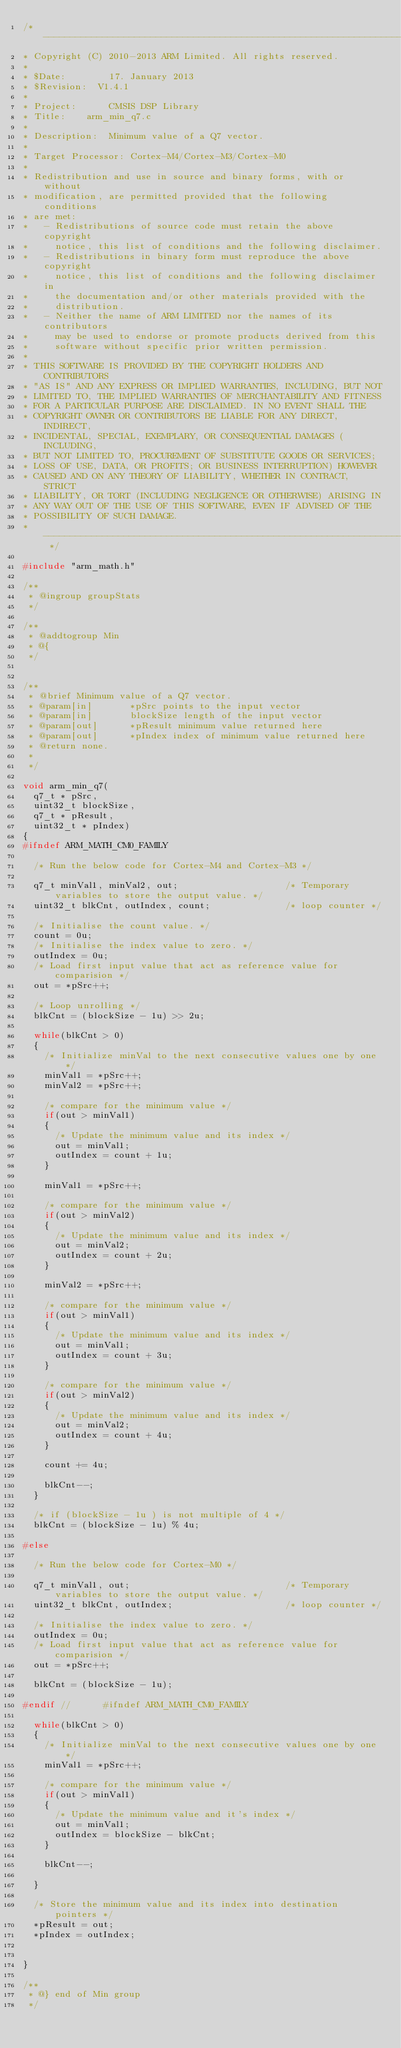<code> <loc_0><loc_0><loc_500><loc_500><_C_>/* ----------------------------------------------------------------------    
* Copyright (C) 2010-2013 ARM Limited. All rights reserved.    
*    
* $Date:        17. January 2013
* $Revision: 	V1.4.1  
*    
* Project: 	    CMSIS DSP Library    
* Title:		arm_min_q7.c    
*    
* Description:	Minimum value of a Q7 vector.    
*    
* Target Processor: Cortex-M4/Cortex-M3/Cortex-M0
*  
* Redistribution and use in source and binary forms, with or without 
* modification, are permitted provided that the following conditions
* are met:
*   - Redistributions of source code must retain the above copyright
*     notice, this list of conditions and the following disclaimer.
*   - Redistributions in binary form must reproduce the above copyright
*     notice, this list of conditions and the following disclaimer in
*     the documentation and/or other materials provided with the 
*     distribution.
*   - Neither the name of ARM LIMITED nor the names of its contributors
*     may be used to endorse or promote products derived from this
*     software without specific prior written permission.
*
* THIS SOFTWARE IS PROVIDED BY THE COPYRIGHT HOLDERS AND CONTRIBUTORS
* "AS IS" AND ANY EXPRESS OR IMPLIED WARRANTIES, INCLUDING, BUT NOT
* LIMITED TO, THE IMPLIED WARRANTIES OF MERCHANTABILITY AND FITNESS
* FOR A PARTICULAR PURPOSE ARE DISCLAIMED. IN NO EVENT SHALL THE 
* COPYRIGHT OWNER OR CONTRIBUTORS BE LIABLE FOR ANY DIRECT, INDIRECT,
* INCIDENTAL, SPECIAL, EXEMPLARY, OR CONSEQUENTIAL DAMAGES (INCLUDING,
* BUT NOT LIMITED TO, PROCUREMENT OF SUBSTITUTE GOODS OR SERVICES;
* LOSS OF USE, DATA, OR PROFITS; OR BUSINESS INTERRUPTION) HOWEVER
* CAUSED AND ON ANY THEORY OF LIABILITY, WHETHER IN CONTRACT, STRICT
* LIABILITY, OR TORT (INCLUDING NEGLIGENCE OR OTHERWISE) ARISING IN
* ANY WAY OUT OF THE USE OF THIS SOFTWARE, EVEN IF ADVISED OF THE
* POSSIBILITY OF SUCH DAMAGE.     
* ---------------------------------------------------------------------------- */

#include "arm_math.h"

/**    
 * @ingroup groupStats    
 */

/**    
 * @addtogroup Min    
 * @{    
 */


/**    
 * @brief Minimum value of a Q7 vector.    
 * @param[in]       *pSrc points to the input vector    
 * @param[in]       blockSize length of the input vector    
 * @param[out]      *pResult minimum value returned here    
 * @param[out]      *pIndex index of minimum value returned here    
 * @return none.    
 *    
 */

void arm_min_q7(
  q7_t * pSrc,
  uint32_t blockSize,
  q7_t * pResult,
  uint32_t * pIndex)
{
#ifndef ARM_MATH_CM0_FAMILY

  /* Run the below code for Cortex-M4 and Cortex-M3 */

  q7_t minVal1, minVal2, out;                    /* Temporary variables to store the output value. */
  uint32_t blkCnt, outIndex, count;              /* loop counter */

  /* Initialise the count value. */
  count = 0u;
  /* Initialise the index value to zero. */
  outIndex = 0u;
  /* Load first input value that act as reference value for comparision */
  out = *pSrc++;

  /* Loop unrolling */
  blkCnt = (blockSize - 1u) >> 2u;

  while(blkCnt > 0)
  {
    /* Initialize minVal to the next consecutive values one by one */
    minVal1 = *pSrc++;
    minVal2 = *pSrc++;

    /* compare for the minimum value */
    if(out > minVal1)
    {
      /* Update the minimum value and its index */
      out = minVal1;
      outIndex = count + 1u;
    }

    minVal1 = *pSrc++;

    /* compare for the minimum value */
    if(out > minVal2)
    {
      /* Update the minimum value and its index */
      out = minVal2;
      outIndex = count + 2u;
    }

    minVal2 = *pSrc++;

    /* compare for the minimum value */
    if(out > minVal1)
    {
      /* Update the minimum value and its index */
      out = minVal1;
      outIndex = count + 3u;
    }

    /* compare for the minimum value */
    if(out > minVal2)
    {
      /* Update the minimum value and its index */
      out = minVal2;
      outIndex = count + 4u;
    }

    count += 4u;

    blkCnt--;
  }

  /* if (blockSize - 1u ) is not multiple of 4 */
  blkCnt = (blockSize - 1u) % 4u;

#else

  /* Run the below code for Cortex-M0 */

  q7_t minVal1, out;                             /* Temporary variables to store the output value. */
  uint32_t blkCnt, outIndex;                     /* loop counter */

  /* Initialise the index value to zero. */
  outIndex = 0u;
  /* Load first input value that act as reference value for comparision */
  out = *pSrc++;

  blkCnt = (blockSize - 1u);

#endif //      #ifndef ARM_MATH_CM0_FAMILY

  while(blkCnt > 0)
  {
    /* Initialize minVal to the next consecutive values one by one */
    minVal1 = *pSrc++;

    /* compare for the minimum value */
    if(out > minVal1)
    {
      /* Update the minimum value and it's index */
      out = minVal1;
      outIndex = blockSize - blkCnt;
    }

    blkCnt--;

  }

  /* Store the minimum value and its index into destination pointers */
  *pResult = out;
  *pIndex = outIndex;


}

/**    
 * @} end of Min group    
 */
</code> 